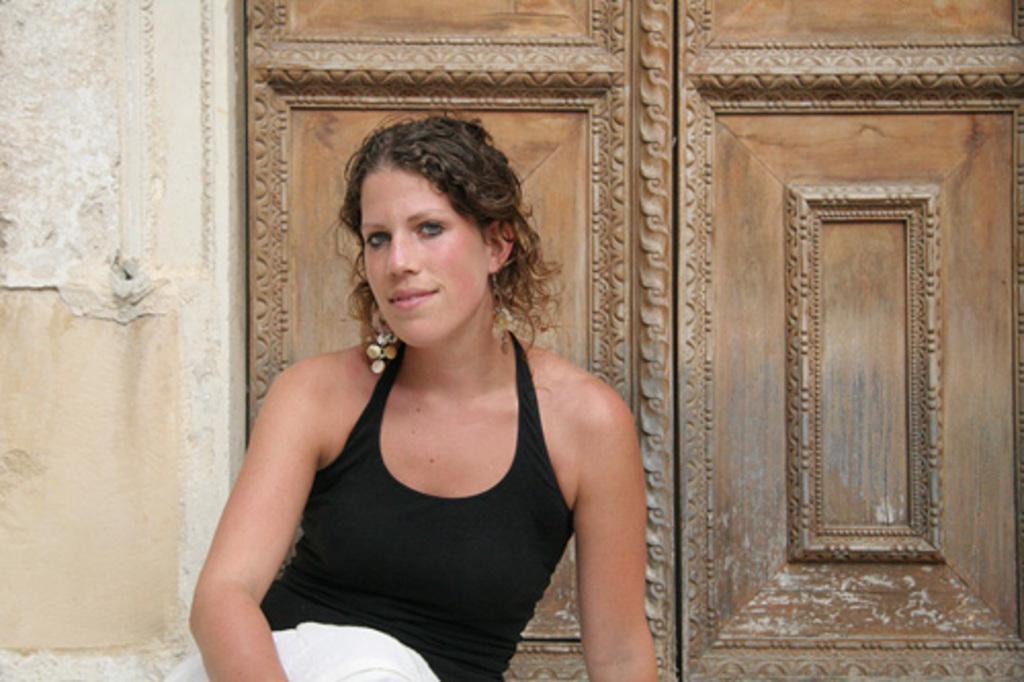Describe this image in one or two sentences. In the picture I can see a woman is sitting and smiling. The woman is wearing black color top. In the background I can see a wall and wooden doors. 